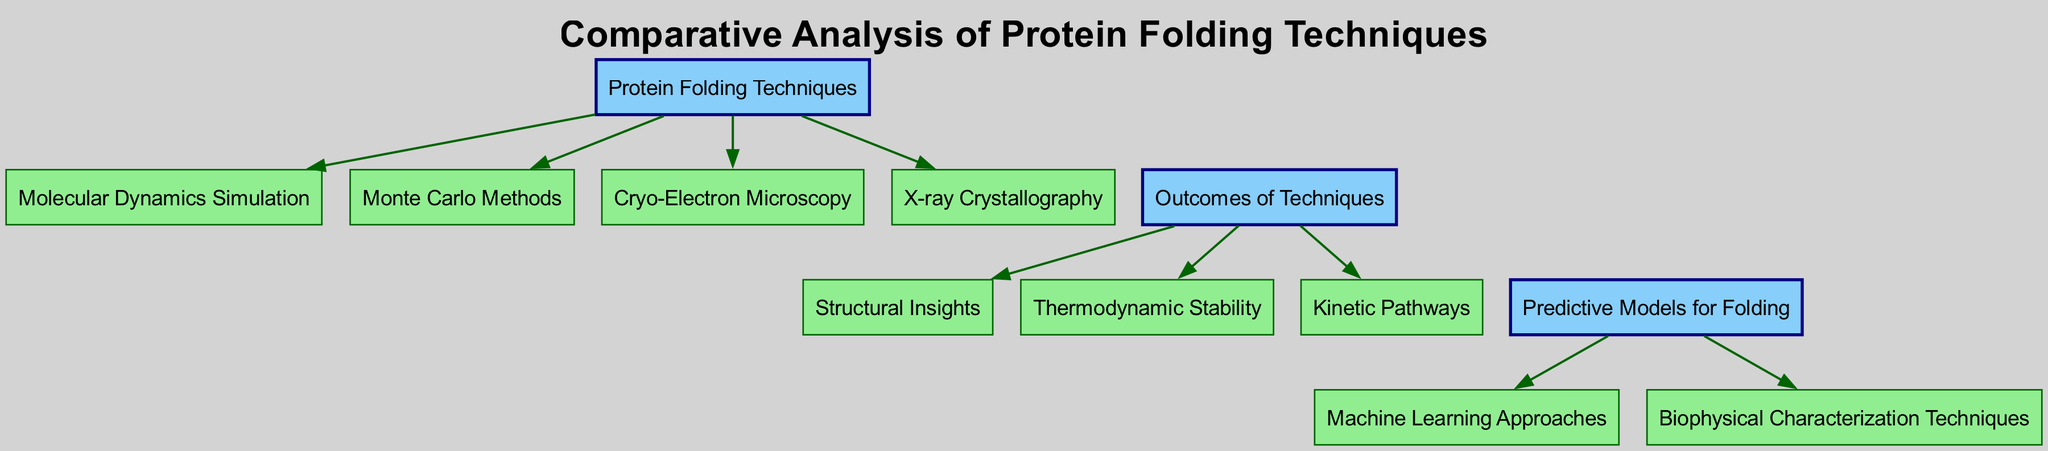What are the main techniques for protein folding listed in the diagram? The diagram lists four main protein folding techniques: Molecular Dynamics Simulation, Monte Carlo Methods, Cryo-Electron Microscopy, and X-ray Crystallography, all of which are subnodes under the main node "Protein Folding Techniques".
Answer: Molecular Dynamics Simulation, Monte Carlo Methods, Cryo-Electron Microscopy, X-ray Crystallography How many outcomes of protein folding techniques are shown? The diagram presents three main outcomes: Structural Insights, Thermodynamic Stability, and Kinetic Pathways, all under the "Outcomes of Techniques" node. Therefore, there are three outcomes shown.
Answer: Three Which technique is associated with Structural Insights? Structural Insights is a subnode directly connected to the node "Outcomes of Techniques". It does not directly link to any specific protein folding technique in the diagram, but is a potential outcome of the listed techniques.
Answer: None What type of approaches are used for predictive models for folding? The "Predictive Models for Folding" node has two subnodes: Machine Learning Approaches and Biophysical Characterization Techniques, indicating the types of approaches utilized.
Answer: Machine Learning Approaches, Biophysical Characterization Techniques Which protein folding technique can provide insights regarding Kinetic Pathways? Kinetic Pathways is an outcome listed under "Outcomes of Techniques". However, the diagram does not specify which technique directly correlates with it, indicating that all listed techniques may contribute to understanding Kinetic Pathways.
Answer: All techniques 